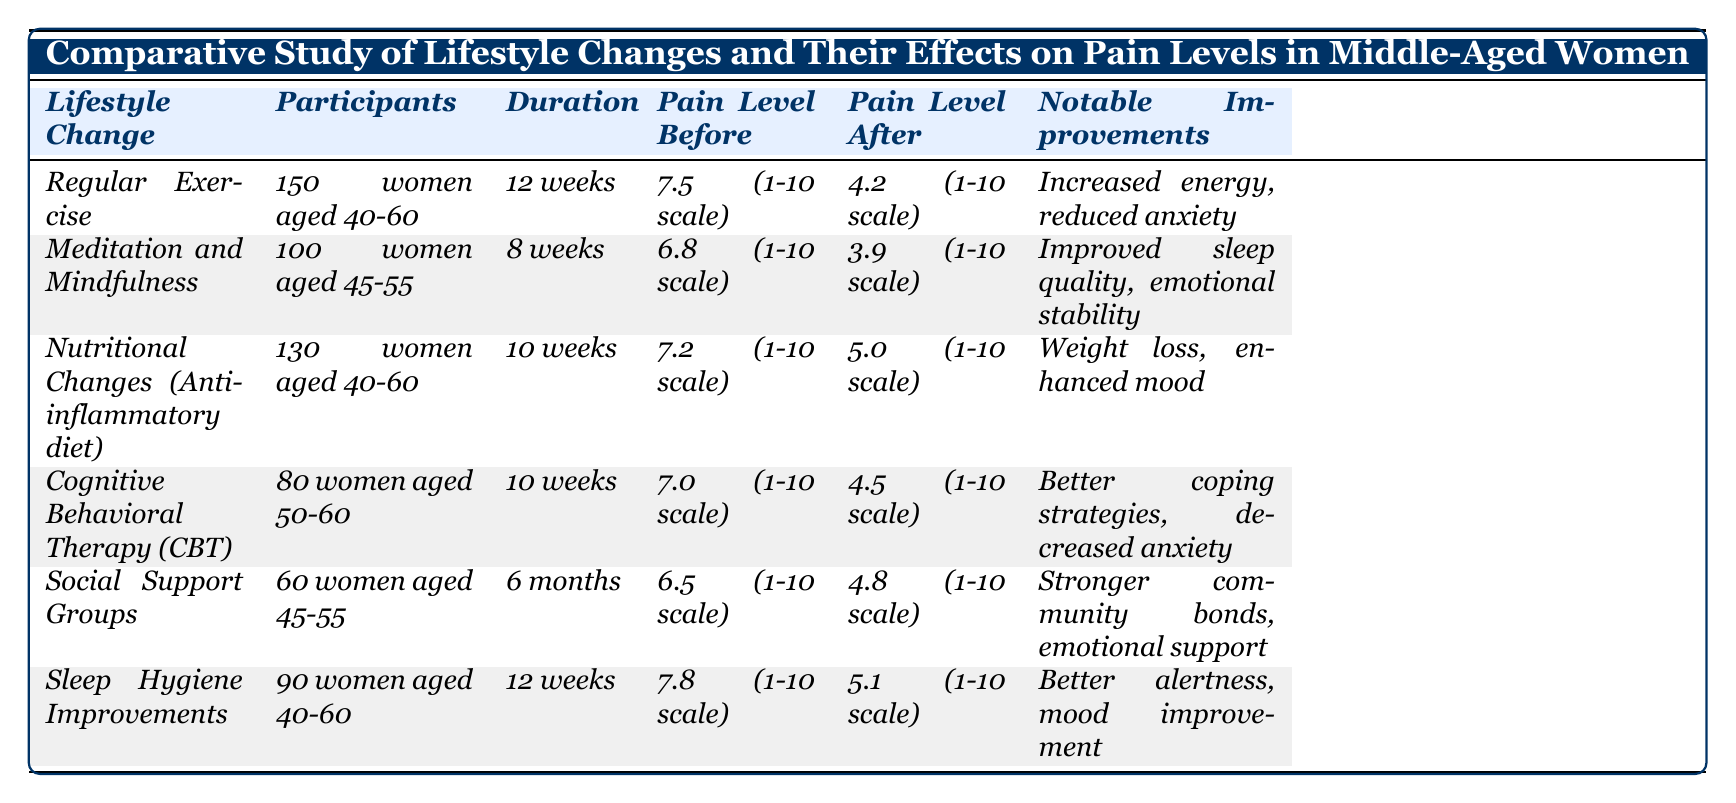what is the duration of the Meditation and Mindfulness program? The table lists the duration for Meditation and Mindfulness as 8 weeks in the corresponding row.
Answer: 8 weeks which lifestyle change had the highest pain level before the intervention? Looking through the "Pain Level Before" column, Regular Exercise has the highest initial pain level at 7.5 (1-10 scale).
Answer: Regular Exercise how many participants were involved in the Sleep Hygiene Improvements group? The "Participants" column shows that 90 women aged 40-60 were involved in the Sleep Hygiene Improvements group.
Answer: 90 women what was the average pain level before the interventions? The pain levels before interventions are 7.5, 6.8, 7.2, 7.0, 6.5, and 7.8. Adding them gives 41.8, and there are 6 data points. So, the average is 41.8 / 6 = 6.97 (rounded to 2 decimal places).
Answer: 6.97 did the Cognitive Behavioral Therapy group see a decrease in pain level? Comparing the "Pain Level Before" (7.0) and "Pain Level After" (4.5) for Cognitive Behavioral Therapy shows a decrease, confirming that the pain level decreased.
Answer: Yes which lifestyle change resulted in the greatest reduction in pain level? The reductions are calculated as follows: Regular Exercise (3.3), Meditation and Mindfulness (2.9), Nutritional Changes (2.2), Cognitive Behavioral Therapy (2.5), Social Support Groups (1.7), and Sleep Hygiene Improvements (2.7). Regular Exercise shows the greatest reduction of 3.3.
Answer: Regular Exercise is there a lifestyle change that includes both nutritional and psychological components? Reviewing the table, only the Nutritional Changes (Anti-inflammatory diet) focuses on dietary changes, while either CBT, Social Support Groups, or Meditation focuses on psychological components; none combine both in this context. Therefore, the answer is no.
Answer: No how many women participated in the Social Support Groups and what was their pain level after the program? According to the table, 60 women participated in the Social Support Groups, and their pain level after the intervention was 4.8 (1-10 scale).
Answer: 60 women, 4.8 what notable improvement was reported for the Meditation and Mindfulness group? The table indicates that notable improvements for the Meditation and Mindfulness group included improved sleep quality and emotional stability.
Answer: Improved sleep quality, emotional stability which group had the lowest pain level after completing their respective program? After comparing the "Pain Level After" values, the Meditation and Mindfulness group had the lowest at 3.9 (1-10 scale).
Answer: Meditation and Mindfulness what was the difference in pain levels for the Nutritional Changes group? The initial pain level was 7.2 and after the intervention it was 5.0, giving a difference of 7.2 - 5.0 = 2.2.
Answer: 2.2 